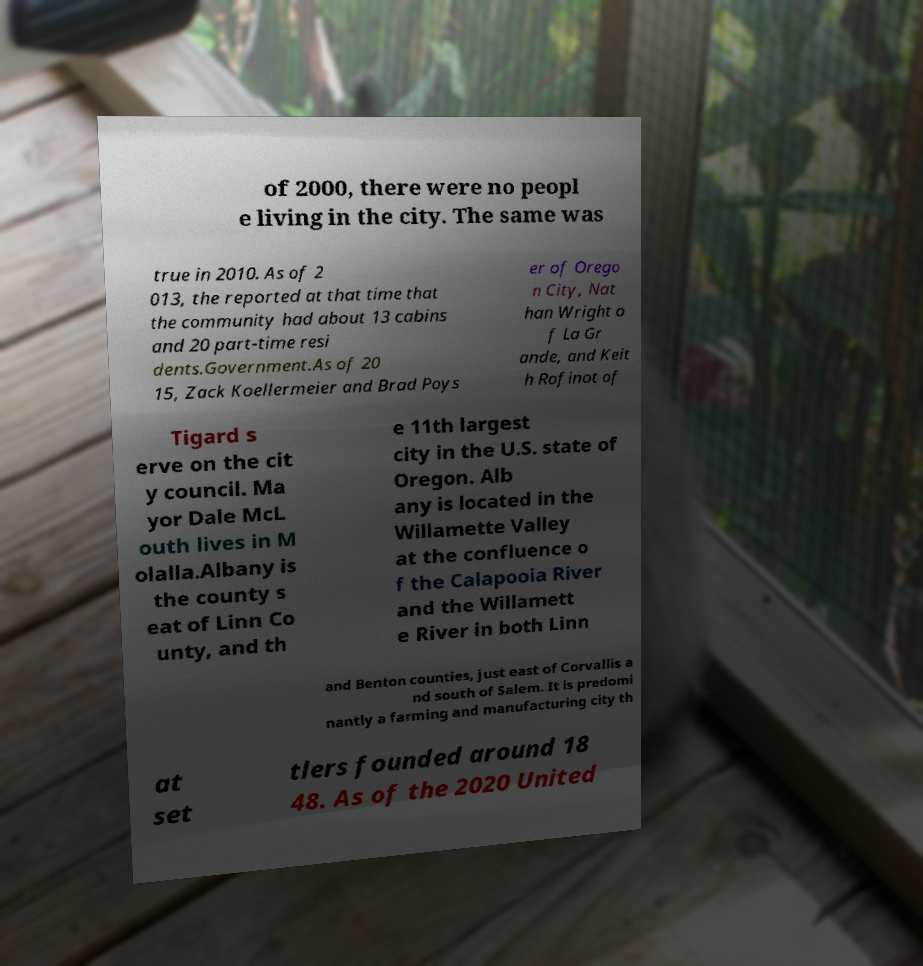Please read and relay the text visible in this image. What does it say? of 2000, there were no peopl e living in the city. The same was true in 2010. As of 2 013, the reported at that time that the community had about 13 cabins and 20 part-time resi dents.Government.As of 20 15, Zack Koellermeier and Brad Poys er of Orego n City, Nat han Wright o f La Gr ande, and Keit h Rofinot of Tigard s erve on the cit y council. Ma yor Dale McL outh lives in M olalla.Albany is the county s eat of Linn Co unty, and th e 11th largest city in the U.S. state of Oregon. Alb any is located in the Willamette Valley at the confluence o f the Calapooia River and the Willamett e River in both Linn and Benton counties, just east of Corvallis a nd south of Salem. It is predomi nantly a farming and manufacturing city th at set tlers founded around 18 48. As of the 2020 United 